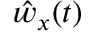<formula> <loc_0><loc_0><loc_500><loc_500>\hat { w } _ { x } ( t )</formula> 